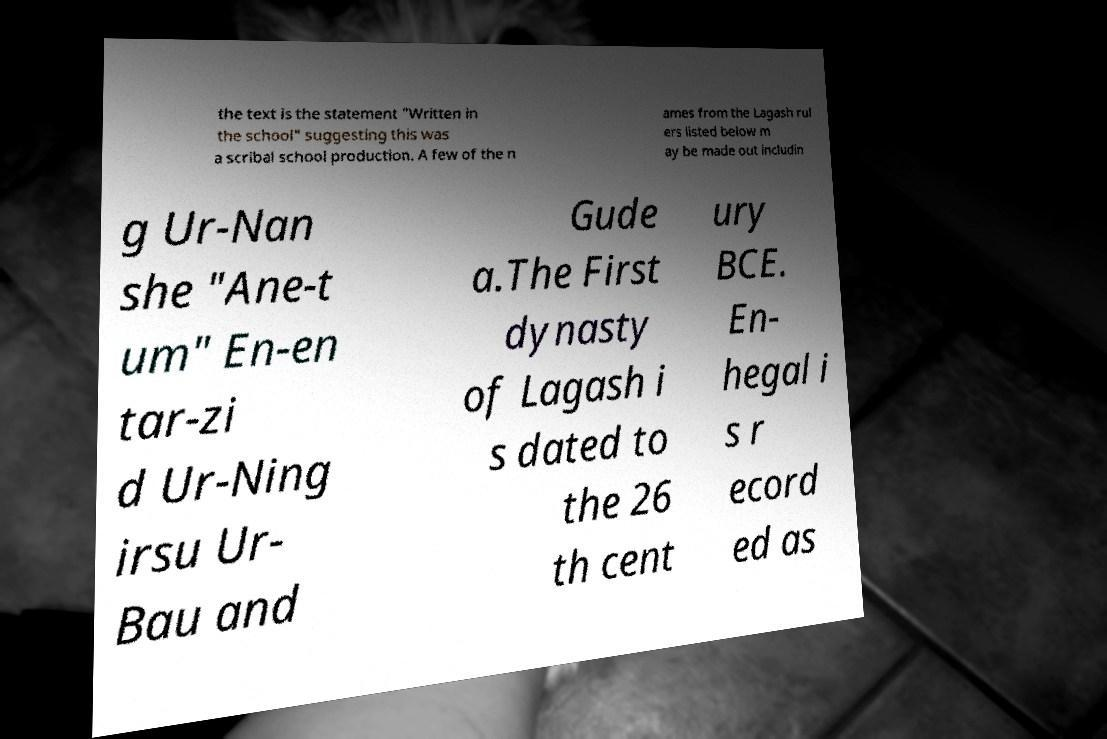What messages or text are displayed in this image? I need them in a readable, typed format. the text is the statement "Written in the school" suggesting this was a scribal school production. A few of the n ames from the Lagash rul ers listed below m ay be made out includin g Ur-Nan she "Ane-t um" En-en tar-zi d Ur-Ning irsu Ur- Bau and Gude a.The First dynasty of Lagash i s dated to the 26 th cent ury BCE. En- hegal i s r ecord ed as 